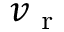Convert formula to latex. <formula><loc_0><loc_0><loc_500><loc_500>v _ { r }</formula> 